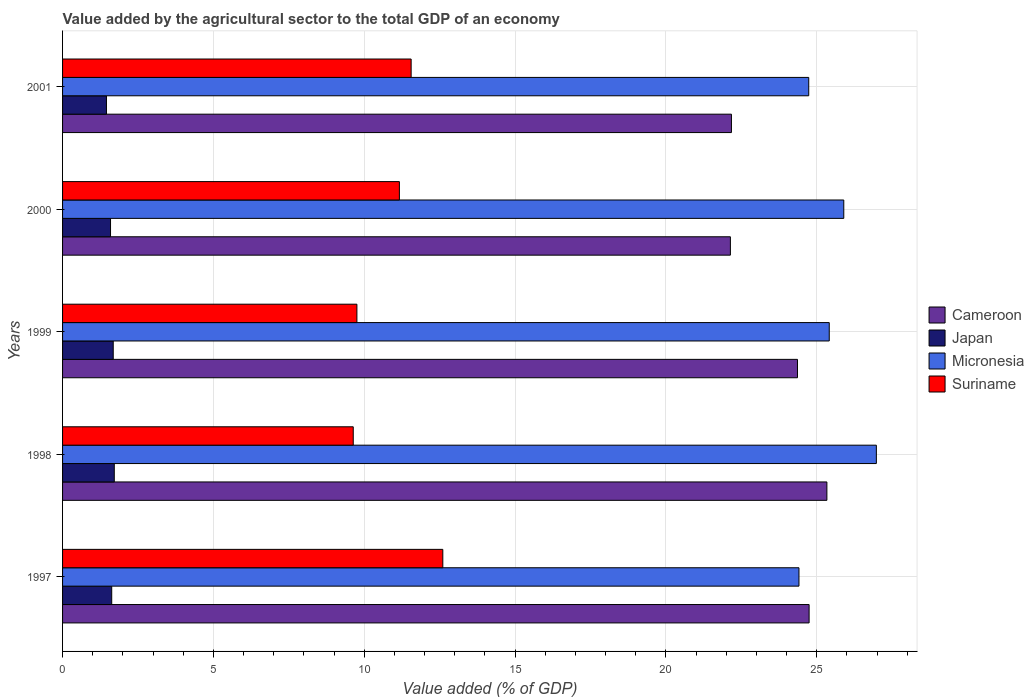How many groups of bars are there?
Provide a short and direct response. 5. What is the label of the 2nd group of bars from the top?
Offer a very short reply. 2000. In how many cases, is the number of bars for a given year not equal to the number of legend labels?
Offer a terse response. 0. What is the value added by the agricultural sector to the total GDP in Suriname in 1998?
Offer a terse response. 9.63. Across all years, what is the maximum value added by the agricultural sector to the total GDP in Micronesia?
Offer a very short reply. 26.97. Across all years, what is the minimum value added by the agricultural sector to the total GDP in Micronesia?
Give a very brief answer. 24.41. What is the total value added by the agricultural sector to the total GDP in Japan in the graph?
Give a very brief answer. 8.07. What is the difference between the value added by the agricultural sector to the total GDP in Suriname in 1998 and that in 2001?
Provide a succinct answer. -1.92. What is the difference between the value added by the agricultural sector to the total GDP in Micronesia in 2000 and the value added by the agricultural sector to the total GDP in Suriname in 1997?
Provide a succinct answer. 13.29. What is the average value added by the agricultural sector to the total GDP in Cameroon per year?
Offer a very short reply. 23.75. In the year 2001, what is the difference between the value added by the agricultural sector to the total GDP in Suriname and value added by the agricultural sector to the total GDP in Micronesia?
Provide a succinct answer. -13.18. What is the ratio of the value added by the agricultural sector to the total GDP in Cameroon in 1998 to that in 2001?
Keep it short and to the point. 1.14. Is the value added by the agricultural sector to the total GDP in Suriname in 1999 less than that in 2001?
Your answer should be compact. Yes. What is the difference between the highest and the second highest value added by the agricultural sector to the total GDP in Micronesia?
Your answer should be compact. 1.08. What is the difference between the highest and the lowest value added by the agricultural sector to the total GDP in Japan?
Your answer should be very brief. 0.26. In how many years, is the value added by the agricultural sector to the total GDP in Cameroon greater than the average value added by the agricultural sector to the total GDP in Cameroon taken over all years?
Provide a short and direct response. 3. Is the sum of the value added by the agricultural sector to the total GDP in Japan in 1997 and 2000 greater than the maximum value added by the agricultural sector to the total GDP in Micronesia across all years?
Offer a terse response. No. Is it the case that in every year, the sum of the value added by the agricultural sector to the total GDP in Micronesia and value added by the agricultural sector to the total GDP in Suriname is greater than the sum of value added by the agricultural sector to the total GDP in Cameroon and value added by the agricultural sector to the total GDP in Japan?
Keep it short and to the point. No. Is it the case that in every year, the sum of the value added by the agricultural sector to the total GDP in Suriname and value added by the agricultural sector to the total GDP in Micronesia is greater than the value added by the agricultural sector to the total GDP in Japan?
Keep it short and to the point. Yes. What is the difference between two consecutive major ticks on the X-axis?
Offer a terse response. 5. Does the graph contain any zero values?
Your response must be concise. No. Does the graph contain grids?
Your answer should be very brief. Yes. Where does the legend appear in the graph?
Provide a short and direct response. Center right. How are the legend labels stacked?
Offer a very short reply. Vertical. What is the title of the graph?
Offer a very short reply. Value added by the agricultural sector to the total GDP of an economy. What is the label or title of the X-axis?
Give a very brief answer. Value added (% of GDP). What is the label or title of the Y-axis?
Make the answer very short. Years. What is the Value added (% of GDP) in Cameroon in 1997?
Provide a succinct answer. 24.74. What is the Value added (% of GDP) in Japan in 1997?
Make the answer very short. 1.63. What is the Value added (% of GDP) in Micronesia in 1997?
Offer a terse response. 24.41. What is the Value added (% of GDP) of Suriname in 1997?
Make the answer very short. 12.6. What is the Value added (% of GDP) in Cameroon in 1998?
Offer a very short reply. 25.33. What is the Value added (% of GDP) in Japan in 1998?
Offer a terse response. 1.71. What is the Value added (% of GDP) of Micronesia in 1998?
Your answer should be very brief. 26.97. What is the Value added (% of GDP) in Suriname in 1998?
Your answer should be very brief. 9.63. What is the Value added (% of GDP) in Cameroon in 1999?
Offer a terse response. 24.36. What is the Value added (% of GDP) in Japan in 1999?
Provide a succinct answer. 1.68. What is the Value added (% of GDP) in Micronesia in 1999?
Your answer should be compact. 25.41. What is the Value added (% of GDP) in Suriname in 1999?
Offer a terse response. 9.76. What is the Value added (% of GDP) of Cameroon in 2000?
Provide a short and direct response. 22.14. What is the Value added (% of GDP) in Japan in 2000?
Provide a succinct answer. 1.59. What is the Value added (% of GDP) in Micronesia in 2000?
Your answer should be compact. 25.89. What is the Value added (% of GDP) of Suriname in 2000?
Your response must be concise. 11.16. What is the Value added (% of GDP) in Cameroon in 2001?
Give a very brief answer. 22.17. What is the Value added (% of GDP) of Japan in 2001?
Offer a terse response. 1.45. What is the Value added (% of GDP) of Micronesia in 2001?
Keep it short and to the point. 24.73. What is the Value added (% of GDP) in Suriname in 2001?
Keep it short and to the point. 11.55. Across all years, what is the maximum Value added (% of GDP) in Cameroon?
Keep it short and to the point. 25.33. Across all years, what is the maximum Value added (% of GDP) in Japan?
Provide a short and direct response. 1.71. Across all years, what is the maximum Value added (% of GDP) of Micronesia?
Your response must be concise. 26.97. Across all years, what is the maximum Value added (% of GDP) in Suriname?
Your response must be concise. 12.6. Across all years, what is the minimum Value added (% of GDP) of Cameroon?
Keep it short and to the point. 22.14. Across all years, what is the minimum Value added (% of GDP) in Japan?
Provide a short and direct response. 1.45. Across all years, what is the minimum Value added (% of GDP) in Micronesia?
Provide a succinct answer. 24.41. Across all years, what is the minimum Value added (% of GDP) of Suriname?
Offer a terse response. 9.63. What is the total Value added (% of GDP) of Cameroon in the graph?
Keep it short and to the point. 118.74. What is the total Value added (% of GDP) in Japan in the graph?
Ensure brevity in your answer.  8.07. What is the total Value added (% of GDP) of Micronesia in the graph?
Provide a short and direct response. 127.42. What is the total Value added (% of GDP) in Suriname in the graph?
Give a very brief answer. 54.71. What is the difference between the Value added (% of GDP) in Cameroon in 1997 and that in 1998?
Your answer should be compact. -0.59. What is the difference between the Value added (% of GDP) in Japan in 1997 and that in 1998?
Your response must be concise. -0.08. What is the difference between the Value added (% of GDP) of Micronesia in 1997 and that in 1998?
Give a very brief answer. -2.57. What is the difference between the Value added (% of GDP) in Suriname in 1997 and that in 1998?
Your answer should be compact. 2.97. What is the difference between the Value added (% of GDP) of Cameroon in 1997 and that in 1999?
Provide a short and direct response. 0.39. What is the difference between the Value added (% of GDP) in Japan in 1997 and that in 1999?
Your response must be concise. -0.05. What is the difference between the Value added (% of GDP) of Micronesia in 1997 and that in 1999?
Provide a short and direct response. -1. What is the difference between the Value added (% of GDP) in Suriname in 1997 and that in 1999?
Keep it short and to the point. 2.85. What is the difference between the Value added (% of GDP) of Cameroon in 1997 and that in 2000?
Your answer should be very brief. 2.61. What is the difference between the Value added (% of GDP) in Japan in 1997 and that in 2000?
Provide a succinct answer. 0.04. What is the difference between the Value added (% of GDP) in Micronesia in 1997 and that in 2000?
Your answer should be very brief. -1.49. What is the difference between the Value added (% of GDP) of Suriname in 1997 and that in 2000?
Make the answer very short. 1.44. What is the difference between the Value added (% of GDP) of Cameroon in 1997 and that in 2001?
Make the answer very short. 2.57. What is the difference between the Value added (% of GDP) in Japan in 1997 and that in 2001?
Ensure brevity in your answer.  0.17. What is the difference between the Value added (% of GDP) in Micronesia in 1997 and that in 2001?
Your answer should be compact. -0.32. What is the difference between the Value added (% of GDP) of Suriname in 1997 and that in 2001?
Offer a very short reply. 1.05. What is the difference between the Value added (% of GDP) in Cameroon in 1998 and that in 1999?
Provide a succinct answer. 0.97. What is the difference between the Value added (% of GDP) of Japan in 1998 and that in 1999?
Ensure brevity in your answer.  0.03. What is the difference between the Value added (% of GDP) in Micronesia in 1998 and that in 1999?
Your answer should be compact. 1.56. What is the difference between the Value added (% of GDP) of Suriname in 1998 and that in 1999?
Your answer should be compact. -0.12. What is the difference between the Value added (% of GDP) in Cameroon in 1998 and that in 2000?
Provide a succinct answer. 3.2. What is the difference between the Value added (% of GDP) in Japan in 1998 and that in 2000?
Ensure brevity in your answer.  0.12. What is the difference between the Value added (% of GDP) in Micronesia in 1998 and that in 2000?
Your response must be concise. 1.08. What is the difference between the Value added (% of GDP) of Suriname in 1998 and that in 2000?
Provide a short and direct response. -1.53. What is the difference between the Value added (% of GDP) in Cameroon in 1998 and that in 2001?
Give a very brief answer. 3.16. What is the difference between the Value added (% of GDP) in Japan in 1998 and that in 2001?
Your answer should be compact. 0.26. What is the difference between the Value added (% of GDP) in Micronesia in 1998 and that in 2001?
Provide a succinct answer. 2.24. What is the difference between the Value added (% of GDP) of Suriname in 1998 and that in 2001?
Make the answer very short. -1.92. What is the difference between the Value added (% of GDP) in Cameroon in 1999 and that in 2000?
Your answer should be compact. 2.22. What is the difference between the Value added (% of GDP) of Japan in 1999 and that in 2000?
Provide a succinct answer. 0.09. What is the difference between the Value added (% of GDP) of Micronesia in 1999 and that in 2000?
Make the answer very short. -0.48. What is the difference between the Value added (% of GDP) in Suriname in 1999 and that in 2000?
Keep it short and to the point. -1.41. What is the difference between the Value added (% of GDP) of Cameroon in 1999 and that in 2001?
Offer a terse response. 2.19. What is the difference between the Value added (% of GDP) of Japan in 1999 and that in 2001?
Offer a very short reply. 0.22. What is the difference between the Value added (% of GDP) of Micronesia in 1999 and that in 2001?
Your answer should be compact. 0.68. What is the difference between the Value added (% of GDP) in Suriname in 1999 and that in 2001?
Your response must be concise. -1.8. What is the difference between the Value added (% of GDP) of Cameroon in 2000 and that in 2001?
Provide a succinct answer. -0.03. What is the difference between the Value added (% of GDP) of Japan in 2000 and that in 2001?
Provide a short and direct response. 0.14. What is the difference between the Value added (% of GDP) in Micronesia in 2000 and that in 2001?
Offer a terse response. 1.16. What is the difference between the Value added (% of GDP) of Suriname in 2000 and that in 2001?
Offer a very short reply. -0.39. What is the difference between the Value added (% of GDP) of Cameroon in 1997 and the Value added (% of GDP) of Japan in 1998?
Ensure brevity in your answer.  23.03. What is the difference between the Value added (% of GDP) of Cameroon in 1997 and the Value added (% of GDP) of Micronesia in 1998?
Provide a short and direct response. -2.23. What is the difference between the Value added (% of GDP) in Cameroon in 1997 and the Value added (% of GDP) in Suriname in 1998?
Give a very brief answer. 15.11. What is the difference between the Value added (% of GDP) in Japan in 1997 and the Value added (% of GDP) in Micronesia in 1998?
Ensure brevity in your answer.  -25.34. What is the difference between the Value added (% of GDP) of Japan in 1997 and the Value added (% of GDP) of Suriname in 1998?
Provide a succinct answer. -8.01. What is the difference between the Value added (% of GDP) of Micronesia in 1997 and the Value added (% of GDP) of Suriname in 1998?
Your answer should be compact. 14.77. What is the difference between the Value added (% of GDP) of Cameroon in 1997 and the Value added (% of GDP) of Japan in 1999?
Ensure brevity in your answer.  23.07. What is the difference between the Value added (% of GDP) in Cameroon in 1997 and the Value added (% of GDP) in Micronesia in 1999?
Keep it short and to the point. -0.67. What is the difference between the Value added (% of GDP) of Cameroon in 1997 and the Value added (% of GDP) of Suriname in 1999?
Your response must be concise. 14.99. What is the difference between the Value added (% of GDP) of Japan in 1997 and the Value added (% of GDP) of Micronesia in 1999?
Keep it short and to the point. -23.78. What is the difference between the Value added (% of GDP) of Japan in 1997 and the Value added (% of GDP) of Suriname in 1999?
Provide a succinct answer. -8.13. What is the difference between the Value added (% of GDP) in Micronesia in 1997 and the Value added (% of GDP) in Suriname in 1999?
Ensure brevity in your answer.  14.65. What is the difference between the Value added (% of GDP) of Cameroon in 1997 and the Value added (% of GDP) of Japan in 2000?
Your answer should be very brief. 23.15. What is the difference between the Value added (% of GDP) of Cameroon in 1997 and the Value added (% of GDP) of Micronesia in 2000?
Make the answer very short. -1.15. What is the difference between the Value added (% of GDP) in Cameroon in 1997 and the Value added (% of GDP) in Suriname in 2000?
Provide a succinct answer. 13.58. What is the difference between the Value added (% of GDP) of Japan in 1997 and the Value added (% of GDP) of Micronesia in 2000?
Offer a very short reply. -24.26. What is the difference between the Value added (% of GDP) of Japan in 1997 and the Value added (% of GDP) of Suriname in 2000?
Give a very brief answer. -9.53. What is the difference between the Value added (% of GDP) of Micronesia in 1997 and the Value added (% of GDP) of Suriname in 2000?
Ensure brevity in your answer.  13.24. What is the difference between the Value added (% of GDP) in Cameroon in 1997 and the Value added (% of GDP) in Japan in 2001?
Your answer should be compact. 23.29. What is the difference between the Value added (% of GDP) in Cameroon in 1997 and the Value added (% of GDP) in Micronesia in 2001?
Offer a terse response. 0.01. What is the difference between the Value added (% of GDP) in Cameroon in 1997 and the Value added (% of GDP) in Suriname in 2001?
Your response must be concise. 13.19. What is the difference between the Value added (% of GDP) of Japan in 1997 and the Value added (% of GDP) of Micronesia in 2001?
Provide a succinct answer. -23.1. What is the difference between the Value added (% of GDP) of Japan in 1997 and the Value added (% of GDP) of Suriname in 2001?
Offer a very short reply. -9.92. What is the difference between the Value added (% of GDP) of Micronesia in 1997 and the Value added (% of GDP) of Suriname in 2001?
Offer a very short reply. 12.85. What is the difference between the Value added (% of GDP) of Cameroon in 1998 and the Value added (% of GDP) of Japan in 1999?
Make the answer very short. 23.65. What is the difference between the Value added (% of GDP) in Cameroon in 1998 and the Value added (% of GDP) in Micronesia in 1999?
Provide a short and direct response. -0.08. What is the difference between the Value added (% of GDP) of Cameroon in 1998 and the Value added (% of GDP) of Suriname in 1999?
Offer a terse response. 15.58. What is the difference between the Value added (% of GDP) of Japan in 1998 and the Value added (% of GDP) of Micronesia in 1999?
Keep it short and to the point. -23.7. What is the difference between the Value added (% of GDP) in Japan in 1998 and the Value added (% of GDP) in Suriname in 1999?
Make the answer very short. -8.04. What is the difference between the Value added (% of GDP) of Micronesia in 1998 and the Value added (% of GDP) of Suriname in 1999?
Your answer should be compact. 17.22. What is the difference between the Value added (% of GDP) in Cameroon in 1998 and the Value added (% of GDP) in Japan in 2000?
Provide a short and direct response. 23.74. What is the difference between the Value added (% of GDP) of Cameroon in 1998 and the Value added (% of GDP) of Micronesia in 2000?
Your answer should be very brief. -0.56. What is the difference between the Value added (% of GDP) of Cameroon in 1998 and the Value added (% of GDP) of Suriname in 2000?
Provide a succinct answer. 14.17. What is the difference between the Value added (% of GDP) in Japan in 1998 and the Value added (% of GDP) in Micronesia in 2000?
Your answer should be compact. -24.18. What is the difference between the Value added (% of GDP) of Japan in 1998 and the Value added (% of GDP) of Suriname in 2000?
Keep it short and to the point. -9.45. What is the difference between the Value added (% of GDP) in Micronesia in 1998 and the Value added (% of GDP) in Suriname in 2000?
Your response must be concise. 15.81. What is the difference between the Value added (% of GDP) in Cameroon in 1998 and the Value added (% of GDP) in Japan in 2001?
Your response must be concise. 23.88. What is the difference between the Value added (% of GDP) of Cameroon in 1998 and the Value added (% of GDP) of Micronesia in 2001?
Offer a very short reply. 0.6. What is the difference between the Value added (% of GDP) of Cameroon in 1998 and the Value added (% of GDP) of Suriname in 2001?
Ensure brevity in your answer.  13.78. What is the difference between the Value added (% of GDP) of Japan in 1998 and the Value added (% of GDP) of Micronesia in 2001?
Your response must be concise. -23.02. What is the difference between the Value added (% of GDP) of Japan in 1998 and the Value added (% of GDP) of Suriname in 2001?
Your answer should be compact. -9.84. What is the difference between the Value added (% of GDP) of Micronesia in 1998 and the Value added (% of GDP) of Suriname in 2001?
Offer a terse response. 15.42. What is the difference between the Value added (% of GDP) of Cameroon in 1999 and the Value added (% of GDP) of Japan in 2000?
Keep it short and to the point. 22.77. What is the difference between the Value added (% of GDP) in Cameroon in 1999 and the Value added (% of GDP) in Micronesia in 2000?
Offer a terse response. -1.53. What is the difference between the Value added (% of GDP) of Cameroon in 1999 and the Value added (% of GDP) of Suriname in 2000?
Make the answer very short. 13.2. What is the difference between the Value added (% of GDP) in Japan in 1999 and the Value added (% of GDP) in Micronesia in 2000?
Offer a very short reply. -24.21. What is the difference between the Value added (% of GDP) in Japan in 1999 and the Value added (% of GDP) in Suriname in 2000?
Give a very brief answer. -9.48. What is the difference between the Value added (% of GDP) of Micronesia in 1999 and the Value added (% of GDP) of Suriname in 2000?
Provide a short and direct response. 14.25. What is the difference between the Value added (% of GDP) of Cameroon in 1999 and the Value added (% of GDP) of Japan in 2001?
Your response must be concise. 22.9. What is the difference between the Value added (% of GDP) of Cameroon in 1999 and the Value added (% of GDP) of Micronesia in 2001?
Provide a short and direct response. -0.37. What is the difference between the Value added (% of GDP) of Cameroon in 1999 and the Value added (% of GDP) of Suriname in 2001?
Offer a very short reply. 12.81. What is the difference between the Value added (% of GDP) of Japan in 1999 and the Value added (% of GDP) of Micronesia in 2001?
Give a very brief answer. -23.05. What is the difference between the Value added (% of GDP) of Japan in 1999 and the Value added (% of GDP) of Suriname in 2001?
Offer a terse response. -9.87. What is the difference between the Value added (% of GDP) in Micronesia in 1999 and the Value added (% of GDP) in Suriname in 2001?
Provide a succinct answer. 13.86. What is the difference between the Value added (% of GDP) in Cameroon in 2000 and the Value added (% of GDP) in Japan in 2001?
Provide a succinct answer. 20.68. What is the difference between the Value added (% of GDP) of Cameroon in 2000 and the Value added (% of GDP) of Micronesia in 2001?
Provide a succinct answer. -2.6. What is the difference between the Value added (% of GDP) in Cameroon in 2000 and the Value added (% of GDP) in Suriname in 2001?
Your answer should be compact. 10.58. What is the difference between the Value added (% of GDP) of Japan in 2000 and the Value added (% of GDP) of Micronesia in 2001?
Provide a succinct answer. -23.14. What is the difference between the Value added (% of GDP) in Japan in 2000 and the Value added (% of GDP) in Suriname in 2001?
Offer a terse response. -9.96. What is the difference between the Value added (% of GDP) in Micronesia in 2000 and the Value added (% of GDP) in Suriname in 2001?
Your answer should be very brief. 14.34. What is the average Value added (% of GDP) of Cameroon per year?
Your answer should be compact. 23.75. What is the average Value added (% of GDP) of Japan per year?
Your answer should be compact. 1.61. What is the average Value added (% of GDP) in Micronesia per year?
Give a very brief answer. 25.48. What is the average Value added (% of GDP) of Suriname per year?
Ensure brevity in your answer.  10.94. In the year 1997, what is the difference between the Value added (% of GDP) in Cameroon and Value added (% of GDP) in Japan?
Your answer should be very brief. 23.11. In the year 1997, what is the difference between the Value added (% of GDP) in Cameroon and Value added (% of GDP) in Micronesia?
Give a very brief answer. 0.34. In the year 1997, what is the difference between the Value added (% of GDP) of Cameroon and Value added (% of GDP) of Suriname?
Give a very brief answer. 12.14. In the year 1997, what is the difference between the Value added (% of GDP) of Japan and Value added (% of GDP) of Micronesia?
Offer a terse response. -22.78. In the year 1997, what is the difference between the Value added (% of GDP) of Japan and Value added (% of GDP) of Suriname?
Provide a short and direct response. -10.97. In the year 1997, what is the difference between the Value added (% of GDP) of Micronesia and Value added (% of GDP) of Suriname?
Your response must be concise. 11.8. In the year 1998, what is the difference between the Value added (% of GDP) in Cameroon and Value added (% of GDP) in Japan?
Your response must be concise. 23.62. In the year 1998, what is the difference between the Value added (% of GDP) of Cameroon and Value added (% of GDP) of Micronesia?
Give a very brief answer. -1.64. In the year 1998, what is the difference between the Value added (% of GDP) of Cameroon and Value added (% of GDP) of Suriname?
Make the answer very short. 15.7. In the year 1998, what is the difference between the Value added (% of GDP) of Japan and Value added (% of GDP) of Micronesia?
Your answer should be very brief. -25.26. In the year 1998, what is the difference between the Value added (% of GDP) of Japan and Value added (% of GDP) of Suriname?
Offer a terse response. -7.92. In the year 1998, what is the difference between the Value added (% of GDP) in Micronesia and Value added (% of GDP) in Suriname?
Your answer should be compact. 17.34. In the year 1999, what is the difference between the Value added (% of GDP) of Cameroon and Value added (% of GDP) of Japan?
Your answer should be very brief. 22.68. In the year 1999, what is the difference between the Value added (% of GDP) of Cameroon and Value added (% of GDP) of Micronesia?
Give a very brief answer. -1.05. In the year 1999, what is the difference between the Value added (% of GDP) in Cameroon and Value added (% of GDP) in Suriname?
Provide a short and direct response. 14.6. In the year 1999, what is the difference between the Value added (% of GDP) in Japan and Value added (% of GDP) in Micronesia?
Provide a short and direct response. -23.73. In the year 1999, what is the difference between the Value added (% of GDP) in Japan and Value added (% of GDP) in Suriname?
Provide a succinct answer. -8.08. In the year 1999, what is the difference between the Value added (% of GDP) in Micronesia and Value added (% of GDP) in Suriname?
Offer a terse response. 15.66. In the year 2000, what is the difference between the Value added (% of GDP) in Cameroon and Value added (% of GDP) in Japan?
Your answer should be compact. 20.55. In the year 2000, what is the difference between the Value added (% of GDP) of Cameroon and Value added (% of GDP) of Micronesia?
Give a very brief answer. -3.76. In the year 2000, what is the difference between the Value added (% of GDP) in Cameroon and Value added (% of GDP) in Suriname?
Provide a short and direct response. 10.97. In the year 2000, what is the difference between the Value added (% of GDP) in Japan and Value added (% of GDP) in Micronesia?
Provide a succinct answer. -24.3. In the year 2000, what is the difference between the Value added (% of GDP) of Japan and Value added (% of GDP) of Suriname?
Provide a short and direct response. -9.57. In the year 2000, what is the difference between the Value added (% of GDP) in Micronesia and Value added (% of GDP) in Suriname?
Keep it short and to the point. 14.73. In the year 2001, what is the difference between the Value added (% of GDP) of Cameroon and Value added (% of GDP) of Japan?
Offer a very short reply. 20.71. In the year 2001, what is the difference between the Value added (% of GDP) of Cameroon and Value added (% of GDP) of Micronesia?
Your answer should be compact. -2.56. In the year 2001, what is the difference between the Value added (% of GDP) of Cameroon and Value added (% of GDP) of Suriname?
Provide a succinct answer. 10.62. In the year 2001, what is the difference between the Value added (% of GDP) of Japan and Value added (% of GDP) of Micronesia?
Your response must be concise. -23.28. In the year 2001, what is the difference between the Value added (% of GDP) in Japan and Value added (% of GDP) in Suriname?
Your answer should be very brief. -10.1. In the year 2001, what is the difference between the Value added (% of GDP) of Micronesia and Value added (% of GDP) of Suriname?
Give a very brief answer. 13.18. What is the ratio of the Value added (% of GDP) of Cameroon in 1997 to that in 1998?
Make the answer very short. 0.98. What is the ratio of the Value added (% of GDP) in Japan in 1997 to that in 1998?
Your answer should be very brief. 0.95. What is the ratio of the Value added (% of GDP) in Micronesia in 1997 to that in 1998?
Make the answer very short. 0.9. What is the ratio of the Value added (% of GDP) in Suriname in 1997 to that in 1998?
Your response must be concise. 1.31. What is the ratio of the Value added (% of GDP) in Cameroon in 1997 to that in 1999?
Provide a short and direct response. 1.02. What is the ratio of the Value added (% of GDP) of Japan in 1997 to that in 1999?
Provide a succinct answer. 0.97. What is the ratio of the Value added (% of GDP) in Micronesia in 1997 to that in 1999?
Your answer should be compact. 0.96. What is the ratio of the Value added (% of GDP) in Suriname in 1997 to that in 1999?
Ensure brevity in your answer.  1.29. What is the ratio of the Value added (% of GDP) of Cameroon in 1997 to that in 2000?
Your answer should be very brief. 1.12. What is the ratio of the Value added (% of GDP) in Japan in 1997 to that in 2000?
Provide a short and direct response. 1.02. What is the ratio of the Value added (% of GDP) in Micronesia in 1997 to that in 2000?
Your response must be concise. 0.94. What is the ratio of the Value added (% of GDP) of Suriname in 1997 to that in 2000?
Give a very brief answer. 1.13. What is the ratio of the Value added (% of GDP) of Cameroon in 1997 to that in 2001?
Your answer should be compact. 1.12. What is the ratio of the Value added (% of GDP) of Japan in 1997 to that in 2001?
Your answer should be very brief. 1.12. What is the ratio of the Value added (% of GDP) of Micronesia in 1997 to that in 2001?
Offer a terse response. 0.99. What is the ratio of the Value added (% of GDP) in Suriname in 1997 to that in 2001?
Your answer should be very brief. 1.09. What is the ratio of the Value added (% of GDP) in Cameroon in 1998 to that in 1999?
Make the answer very short. 1.04. What is the ratio of the Value added (% of GDP) in Japan in 1998 to that in 1999?
Offer a very short reply. 1.02. What is the ratio of the Value added (% of GDP) in Micronesia in 1998 to that in 1999?
Your answer should be very brief. 1.06. What is the ratio of the Value added (% of GDP) in Suriname in 1998 to that in 1999?
Keep it short and to the point. 0.99. What is the ratio of the Value added (% of GDP) in Cameroon in 1998 to that in 2000?
Make the answer very short. 1.14. What is the ratio of the Value added (% of GDP) of Japan in 1998 to that in 2000?
Give a very brief answer. 1.08. What is the ratio of the Value added (% of GDP) of Micronesia in 1998 to that in 2000?
Offer a very short reply. 1.04. What is the ratio of the Value added (% of GDP) of Suriname in 1998 to that in 2000?
Provide a succinct answer. 0.86. What is the ratio of the Value added (% of GDP) of Cameroon in 1998 to that in 2001?
Your response must be concise. 1.14. What is the ratio of the Value added (% of GDP) in Japan in 1998 to that in 2001?
Offer a very short reply. 1.18. What is the ratio of the Value added (% of GDP) of Micronesia in 1998 to that in 2001?
Give a very brief answer. 1.09. What is the ratio of the Value added (% of GDP) of Suriname in 1998 to that in 2001?
Offer a very short reply. 0.83. What is the ratio of the Value added (% of GDP) in Cameroon in 1999 to that in 2000?
Your answer should be very brief. 1.1. What is the ratio of the Value added (% of GDP) in Japan in 1999 to that in 2000?
Your answer should be very brief. 1.06. What is the ratio of the Value added (% of GDP) in Micronesia in 1999 to that in 2000?
Offer a terse response. 0.98. What is the ratio of the Value added (% of GDP) in Suriname in 1999 to that in 2000?
Give a very brief answer. 0.87. What is the ratio of the Value added (% of GDP) in Cameroon in 1999 to that in 2001?
Your answer should be compact. 1.1. What is the ratio of the Value added (% of GDP) in Japan in 1999 to that in 2001?
Your answer should be very brief. 1.15. What is the ratio of the Value added (% of GDP) in Micronesia in 1999 to that in 2001?
Offer a very short reply. 1.03. What is the ratio of the Value added (% of GDP) of Suriname in 1999 to that in 2001?
Provide a succinct answer. 0.84. What is the ratio of the Value added (% of GDP) in Cameroon in 2000 to that in 2001?
Your answer should be compact. 1. What is the ratio of the Value added (% of GDP) in Japan in 2000 to that in 2001?
Your answer should be compact. 1.09. What is the ratio of the Value added (% of GDP) in Micronesia in 2000 to that in 2001?
Offer a terse response. 1.05. What is the ratio of the Value added (% of GDP) of Suriname in 2000 to that in 2001?
Offer a terse response. 0.97. What is the difference between the highest and the second highest Value added (% of GDP) of Cameroon?
Keep it short and to the point. 0.59. What is the difference between the highest and the second highest Value added (% of GDP) in Japan?
Your answer should be compact. 0.03. What is the difference between the highest and the second highest Value added (% of GDP) of Micronesia?
Offer a terse response. 1.08. What is the difference between the highest and the second highest Value added (% of GDP) of Suriname?
Provide a short and direct response. 1.05. What is the difference between the highest and the lowest Value added (% of GDP) in Cameroon?
Offer a very short reply. 3.2. What is the difference between the highest and the lowest Value added (% of GDP) of Japan?
Provide a succinct answer. 0.26. What is the difference between the highest and the lowest Value added (% of GDP) in Micronesia?
Provide a short and direct response. 2.57. What is the difference between the highest and the lowest Value added (% of GDP) of Suriname?
Your answer should be very brief. 2.97. 